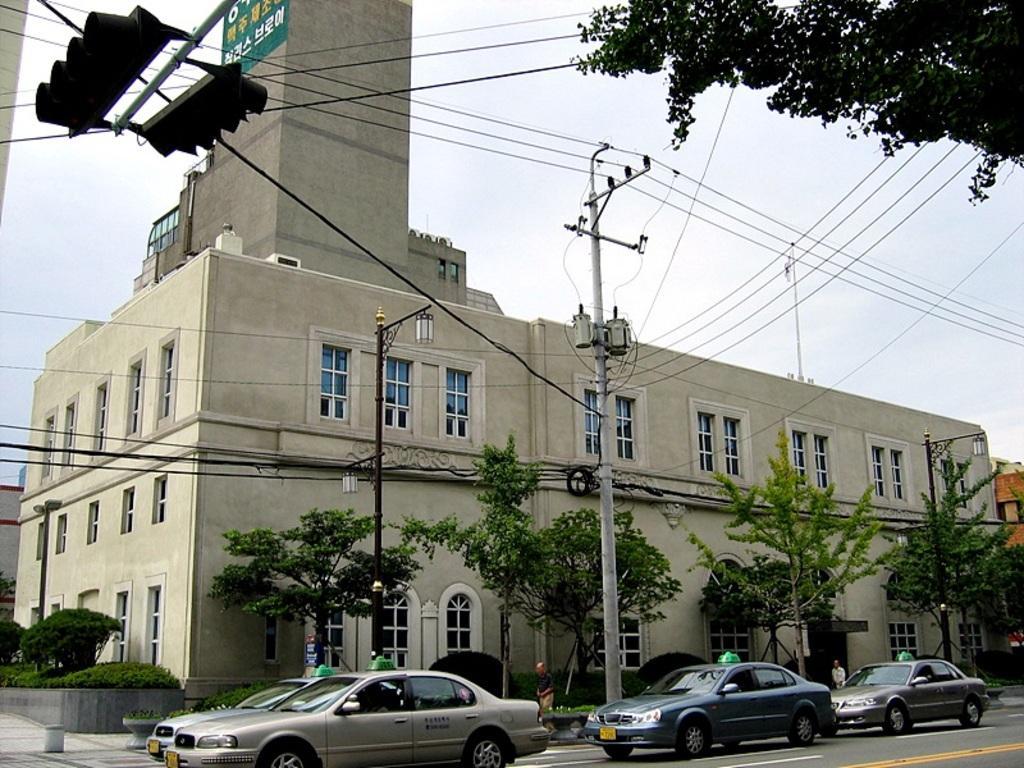Describe this image in one or two sentences. In this image there are few cars on the road. Few persons are walking on the pavement having a pole and a street light which are connected with wires. Left top there is a pole having two traffic lights attached to it. Left side there are few plants behind the wall. There are few trees on the pavement. Behind there are buildings. Top of the image there is sky. Right top there is a tree. 